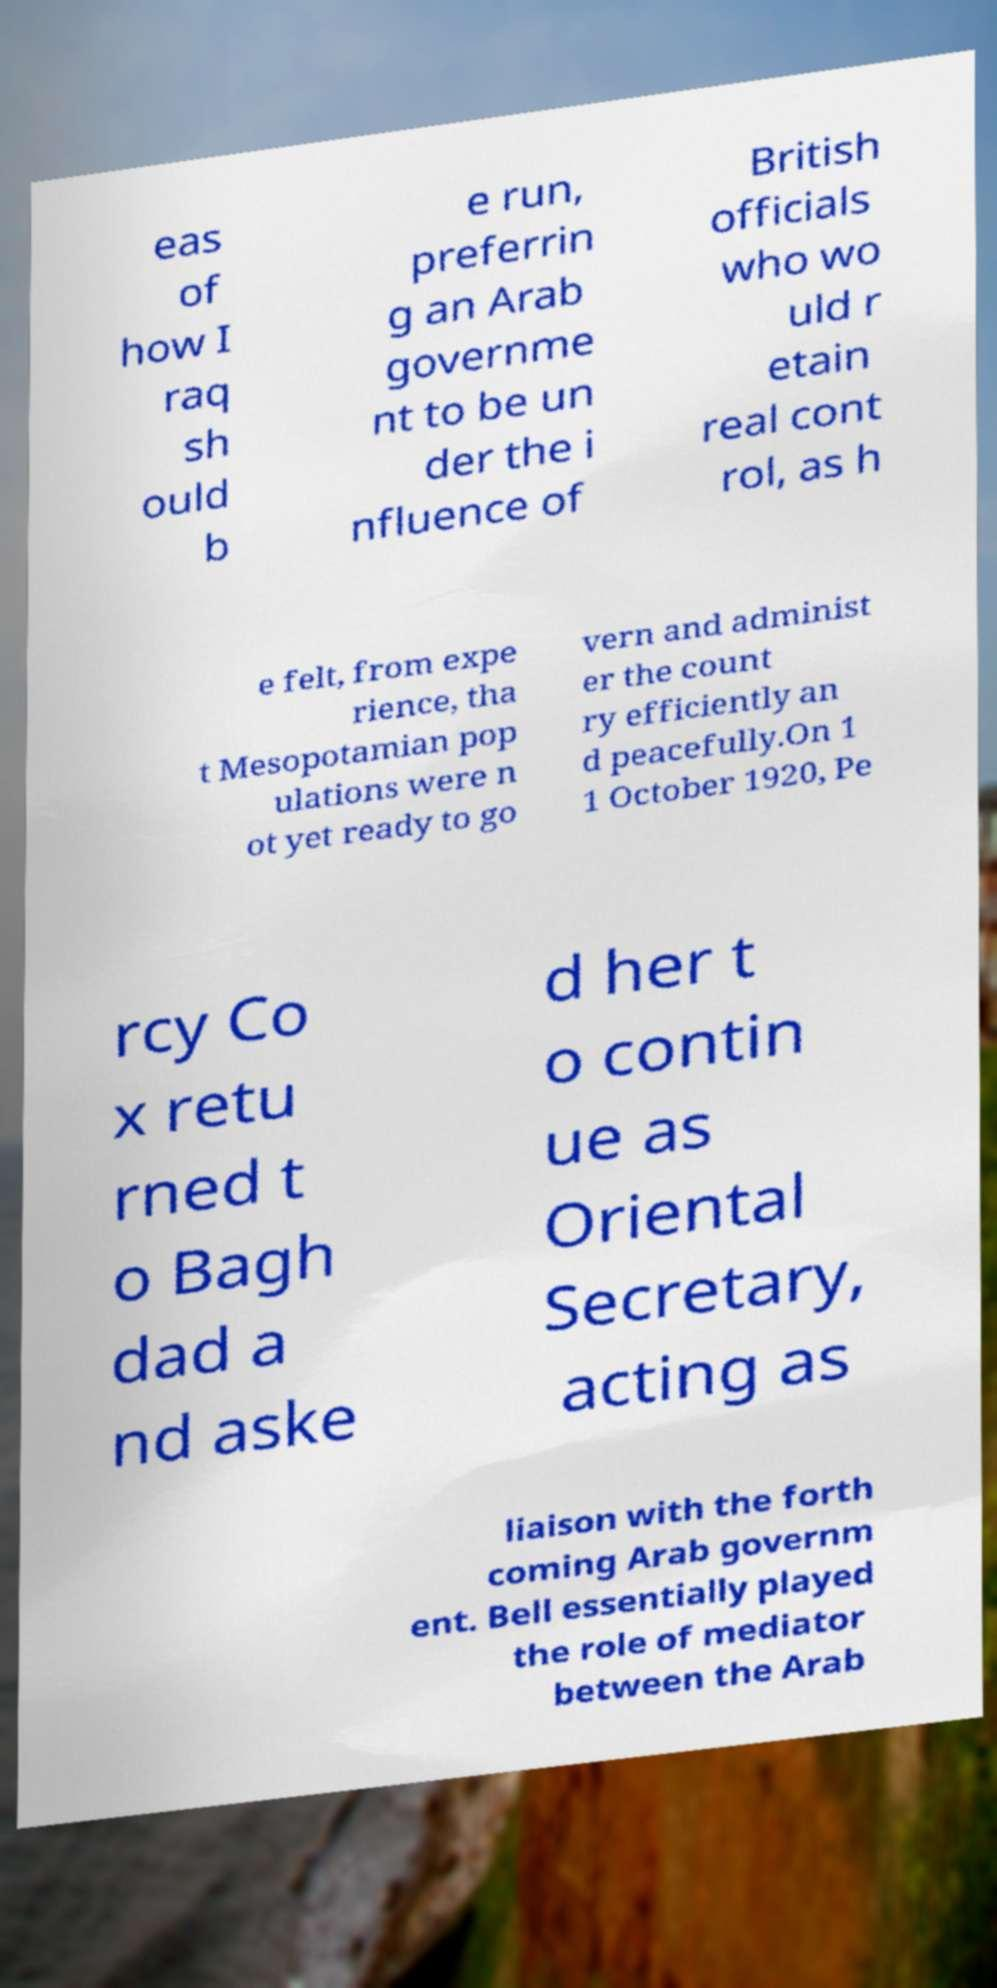Please identify and transcribe the text found in this image. eas of how I raq sh ould b e run, preferrin g an Arab governme nt to be un der the i nfluence of British officials who wo uld r etain real cont rol, as h e felt, from expe rience, tha t Mesopotamian pop ulations were n ot yet ready to go vern and administ er the count ry efficiently an d peacefully.On 1 1 October 1920, Pe rcy Co x retu rned t o Bagh dad a nd aske d her t o contin ue as Oriental Secretary, acting as liaison with the forth coming Arab governm ent. Bell essentially played the role of mediator between the Arab 